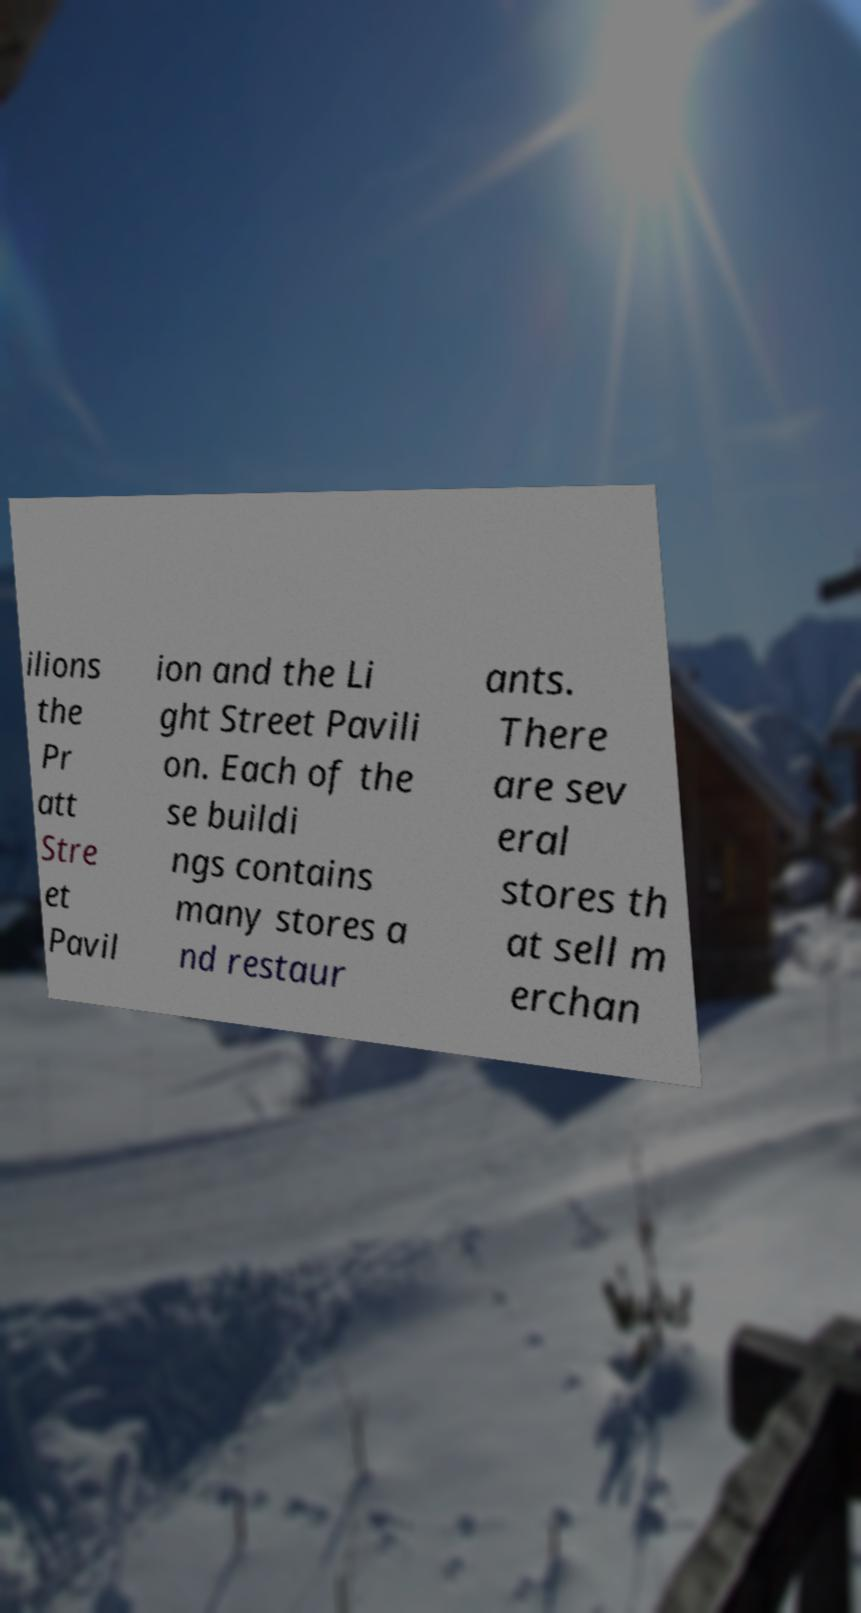Can you read and provide the text displayed in the image?This photo seems to have some interesting text. Can you extract and type it out for me? ilions the Pr att Stre et Pavil ion and the Li ght Street Pavili on. Each of the se buildi ngs contains many stores a nd restaur ants. There are sev eral stores th at sell m erchan 